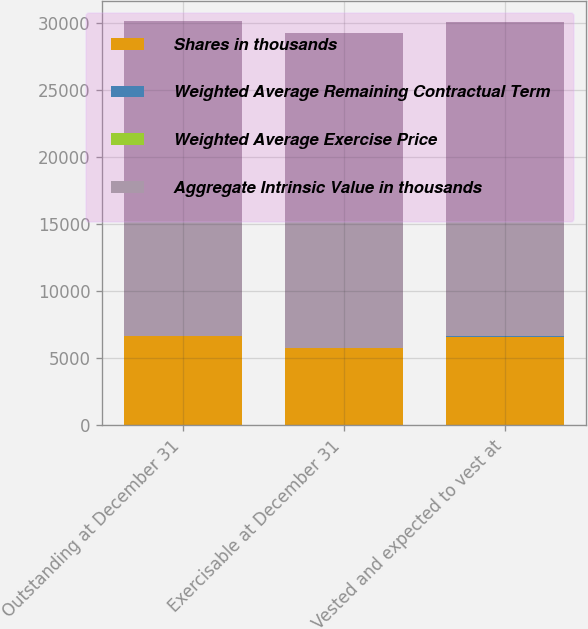<chart> <loc_0><loc_0><loc_500><loc_500><stacked_bar_chart><ecel><fcel>Outstanding at December 31<fcel>Exercisable at December 31<fcel>Vested and expected to vest at<nl><fcel>Shares in thousands<fcel>6642<fcel>5732<fcel>6597<nl><fcel>Weighted Average Remaining Contractual Term<fcel>21.64<fcel>20.81<fcel>21.61<nl><fcel>Weighted Average Exercise Price<fcel>4.7<fcel>4.1<fcel>4.7<nl><fcel>Aggregate Intrinsic Value in thousands<fcel>23464<fcel>23454<fcel>23463<nl></chart> 